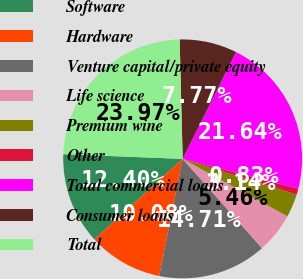Convert chart to OTSL. <chart><loc_0><loc_0><loc_500><loc_500><pie_chart><fcel>Software<fcel>Hardware<fcel>Venture capital/private equity<fcel>Life science<fcel>Premium wine<fcel>Other<fcel>Total commercial loans<fcel>Consumer loans<fcel>Total<nl><fcel>12.4%<fcel>10.08%<fcel>14.71%<fcel>5.46%<fcel>3.14%<fcel>0.83%<fcel>21.64%<fcel>7.77%<fcel>23.97%<nl></chart> 